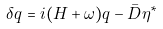Convert formula to latex. <formula><loc_0><loc_0><loc_500><loc_500>\delta q = i ( H + \omega ) q - \bar { D } \eta ^ { * }</formula> 